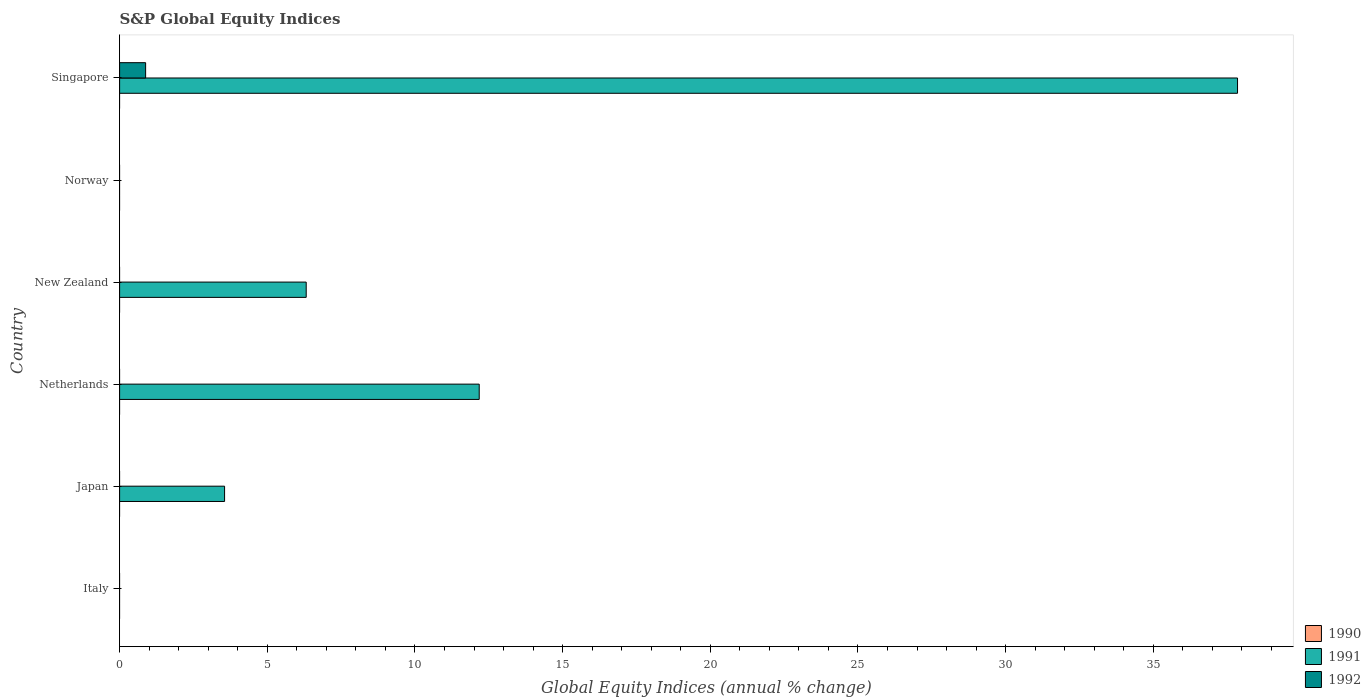How many different coloured bars are there?
Your answer should be compact. 2. Are the number of bars on each tick of the Y-axis equal?
Your response must be concise. No. How many bars are there on the 1st tick from the top?
Offer a very short reply. 2. What is the label of the 3rd group of bars from the top?
Your answer should be compact. New Zealand. What is the global equity indices in 1990 in Japan?
Make the answer very short. 0. Across all countries, what is the maximum global equity indices in 1991?
Give a very brief answer. 37.85. Across all countries, what is the minimum global equity indices in 1990?
Your answer should be compact. 0. In which country was the global equity indices in 1991 maximum?
Keep it short and to the point. Singapore. What is the total global equity indices in 1990 in the graph?
Provide a succinct answer. 0. What is the difference between the global equity indices in 1991 in Japan and that in New Zealand?
Your answer should be very brief. -2.76. What is the average global equity indices in 1992 per country?
Provide a short and direct response. 0.15. What is the difference between the global equity indices in 1991 and global equity indices in 1992 in Singapore?
Your answer should be compact. 36.97. What is the difference between the highest and the second highest global equity indices in 1991?
Your answer should be compact. 25.68. What is the difference between the highest and the lowest global equity indices in 1992?
Provide a succinct answer. 0.88. How many bars are there?
Your answer should be very brief. 5. How many countries are there in the graph?
Your answer should be compact. 6. What is the difference between two consecutive major ticks on the X-axis?
Provide a short and direct response. 5. Are the values on the major ticks of X-axis written in scientific E-notation?
Provide a short and direct response. No. Does the graph contain grids?
Keep it short and to the point. No. What is the title of the graph?
Give a very brief answer. S&P Global Equity Indices. Does "1997" appear as one of the legend labels in the graph?
Your answer should be compact. No. What is the label or title of the X-axis?
Ensure brevity in your answer.  Global Equity Indices (annual % change). What is the Global Equity Indices (annual % change) in 1991 in Italy?
Your answer should be compact. 0. What is the Global Equity Indices (annual % change) in 1992 in Italy?
Your answer should be compact. 0. What is the Global Equity Indices (annual % change) in 1991 in Japan?
Your response must be concise. 3.55. What is the Global Equity Indices (annual % change) of 1990 in Netherlands?
Offer a terse response. 0. What is the Global Equity Indices (annual % change) of 1991 in Netherlands?
Offer a very short reply. 12.18. What is the Global Equity Indices (annual % change) in 1991 in New Zealand?
Keep it short and to the point. 6.32. What is the Global Equity Indices (annual % change) of 1991 in Norway?
Make the answer very short. 0. What is the Global Equity Indices (annual % change) of 1992 in Norway?
Provide a short and direct response. 0. What is the Global Equity Indices (annual % change) of 1990 in Singapore?
Offer a very short reply. 0. What is the Global Equity Indices (annual % change) in 1991 in Singapore?
Give a very brief answer. 37.85. What is the Global Equity Indices (annual % change) in 1992 in Singapore?
Give a very brief answer. 0.88. Across all countries, what is the maximum Global Equity Indices (annual % change) of 1991?
Offer a terse response. 37.85. Across all countries, what is the maximum Global Equity Indices (annual % change) in 1992?
Provide a short and direct response. 0.88. Across all countries, what is the minimum Global Equity Indices (annual % change) in 1991?
Ensure brevity in your answer.  0. Across all countries, what is the minimum Global Equity Indices (annual % change) in 1992?
Provide a short and direct response. 0. What is the total Global Equity Indices (annual % change) in 1990 in the graph?
Offer a very short reply. 0. What is the total Global Equity Indices (annual % change) in 1991 in the graph?
Provide a succinct answer. 59.9. What is the total Global Equity Indices (annual % change) of 1992 in the graph?
Make the answer very short. 0.88. What is the difference between the Global Equity Indices (annual % change) of 1991 in Japan and that in Netherlands?
Your answer should be compact. -8.62. What is the difference between the Global Equity Indices (annual % change) of 1991 in Japan and that in New Zealand?
Make the answer very short. -2.76. What is the difference between the Global Equity Indices (annual % change) of 1991 in Japan and that in Singapore?
Your answer should be very brief. -34.3. What is the difference between the Global Equity Indices (annual % change) in 1991 in Netherlands and that in New Zealand?
Your answer should be compact. 5.86. What is the difference between the Global Equity Indices (annual % change) of 1991 in Netherlands and that in Singapore?
Give a very brief answer. -25.68. What is the difference between the Global Equity Indices (annual % change) in 1991 in New Zealand and that in Singapore?
Keep it short and to the point. -31.53. What is the difference between the Global Equity Indices (annual % change) in 1991 in Japan and the Global Equity Indices (annual % change) in 1992 in Singapore?
Make the answer very short. 2.67. What is the difference between the Global Equity Indices (annual % change) of 1991 in Netherlands and the Global Equity Indices (annual % change) of 1992 in Singapore?
Give a very brief answer. 11.3. What is the difference between the Global Equity Indices (annual % change) in 1991 in New Zealand and the Global Equity Indices (annual % change) in 1992 in Singapore?
Ensure brevity in your answer.  5.44. What is the average Global Equity Indices (annual % change) in 1991 per country?
Keep it short and to the point. 9.98. What is the average Global Equity Indices (annual % change) of 1992 per country?
Ensure brevity in your answer.  0.15. What is the difference between the Global Equity Indices (annual % change) in 1991 and Global Equity Indices (annual % change) in 1992 in Singapore?
Provide a short and direct response. 36.97. What is the ratio of the Global Equity Indices (annual % change) of 1991 in Japan to that in Netherlands?
Offer a very short reply. 0.29. What is the ratio of the Global Equity Indices (annual % change) of 1991 in Japan to that in New Zealand?
Keep it short and to the point. 0.56. What is the ratio of the Global Equity Indices (annual % change) of 1991 in Japan to that in Singapore?
Give a very brief answer. 0.09. What is the ratio of the Global Equity Indices (annual % change) of 1991 in Netherlands to that in New Zealand?
Your answer should be compact. 1.93. What is the ratio of the Global Equity Indices (annual % change) in 1991 in Netherlands to that in Singapore?
Keep it short and to the point. 0.32. What is the ratio of the Global Equity Indices (annual % change) of 1991 in New Zealand to that in Singapore?
Offer a very short reply. 0.17. What is the difference between the highest and the second highest Global Equity Indices (annual % change) of 1991?
Your answer should be compact. 25.68. What is the difference between the highest and the lowest Global Equity Indices (annual % change) of 1991?
Offer a terse response. 37.85. What is the difference between the highest and the lowest Global Equity Indices (annual % change) in 1992?
Give a very brief answer. 0.88. 